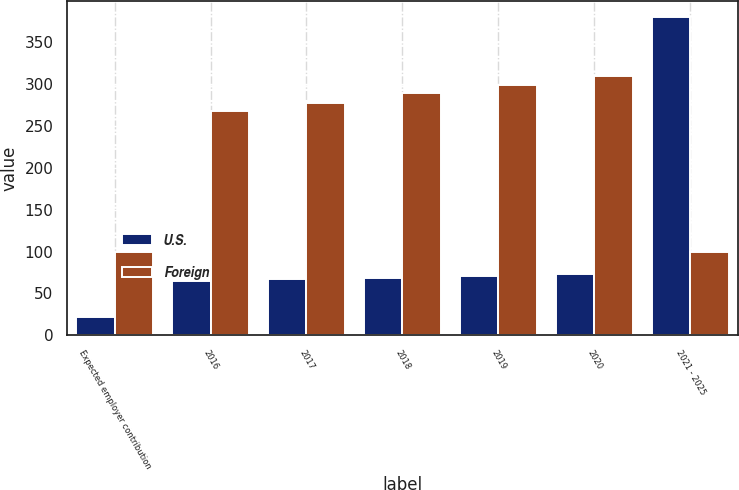Convert chart. <chart><loc_0><loc_0><loc_500><loc_500><stacked_bar_chart><ecel><fcel>Expected employer contribution<fcel>2016<fcel>2017<fcel>2018<fcel>2019<fcel>2020<fcel>2021 - 2025<nl><fcel>U.S.<fcel>22<fcel>65<fcel>67<fcel>69<fcel>71<fcel>73<fcel>380<nl><fcel>Foreign<fcel>100<fcel>268<fcel>277<fcel>289<fcel>299<fcel>309<fcel>100<nl></chart> 